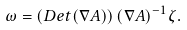Convert formula to latex. <formula><loc_0><loc_0><loc_500><loc_500>\omega = \left ( D e t ( \nabla A ) \right ) ( \nabla A ) ^ { - 1 } \zeta .</formula> 